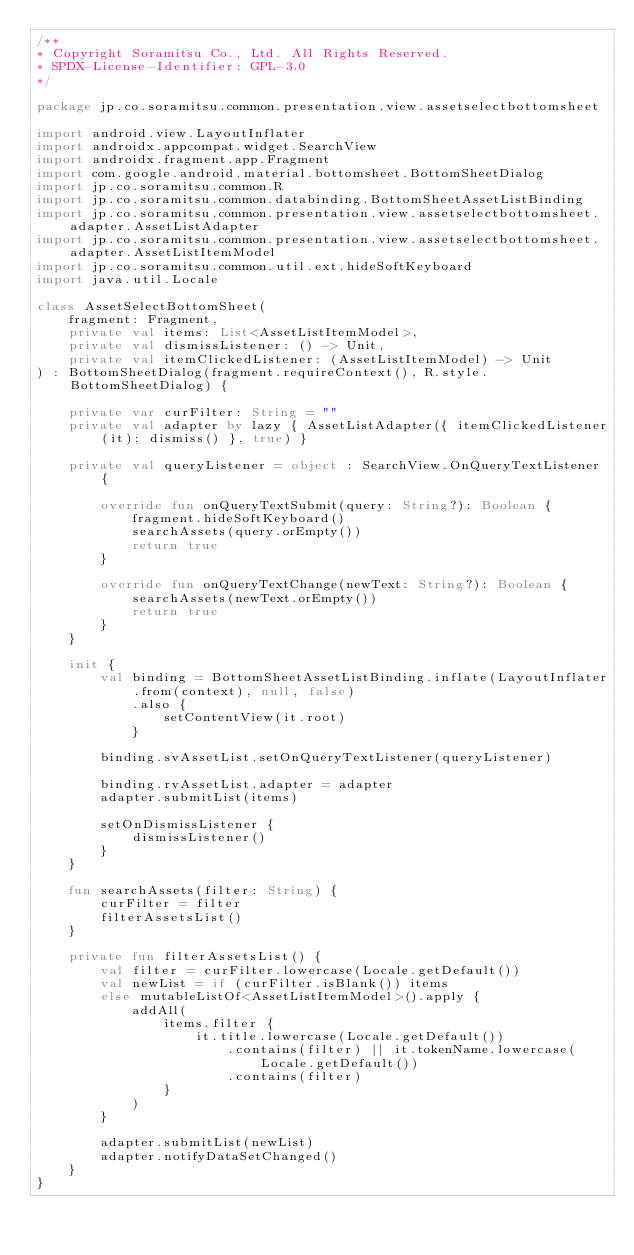Convert code to text. <code><loc_0><loc_0><loc_500><loc_500><_Kotlin_>/**
* Copyright Soramitsu Co., Ltd. All Rights Reserved.
* SPDX-License-Identifier: GPL-3.0
*/

package jp.co.soramitsu.common.presentation.view.assetselectbottomsheet

import android.view.LayoutInflater
import androidx.appcompat.widget.SearchView
import androidx.fragment.app.Fragment
import com.google.android.material.bottomsheet.BottomSheetDialog
import jp.co.soramitsu.common.R
import jp.co.soramitsu.common.databinding.BottomSheetAssetListBinding
import jp.co.soramitsu.common.presentation.view.assetselectbottomsheet.adapter.AssetListAdapter
import jp.co.soramitsu.common.presentation.view.assetselectbottomsheet.adapter.AssetListItemModel
import jp.co.soramitsu.common.util.ext.hideSoftKeyboard
import java.util.Locale

class AssetSelectBottomSheet(
    fragment: Fragment,
    private val items: List<AssetListItemModel>,
    private val dismissListener: () -> Unit,
    private val itemClickedListener: (AssetListItemModel) -> Unit
) : BottomSheetDialog(fragment.requireContext(), R.style.BottomSheetDialog) {

    private var curFilter: String = ""
    private val adapter by lazy { AssetListAdapter({ itemClickedListener(it); dismiss() }, true) }

    private val queryListener = object : SearchView.OnQueryTextListener {

        override fun onQueryTextSubmit(query: String?): Boolean {
            fragment.hideSoftKeyboard()
            searchAssets(query.orEmpty())
            return true
        }

        override fun onQueryTextChange(newText: String?): Boolean {
            searchAssets(newText.orEmpty())
            return true
        }
    }

    init {
        val binding = BottomSheetAssetListBinding.inflate(LayoutInflater.from(context), null, false)
            .also {
                setContentView(it.root)
            }

        binding.svAssetList.setOnQueryTextListener(queryListener)

        binding.rvAssetList.adapter = adapter
        adapter.submitList(items)

        setOnDismissListener {
            dismissListener()
        }
    }

    fun searchAssets(filter: String) {
        curFilter = filter
        filterAssetsList()
    }

    private fun filterAssetsList() {
        val filter = curFilter.lowercase(Locale.getDefault())
        val newList = if (curFilter.isBlank()) items
        else mutableListOf<AssetListItemModel>().apply {
            addAll(
                items.filter {
                    it.title.lowercase(Locale.getDefault())
                        .contains(filter) || it.tokenName.lowercase(Locale.getDefault())
                        .contains(filter)
                }
            )
        }

        adapter.submitList(newList)
        adapter.notifyDataSetChanged()
    }
}
</code> 